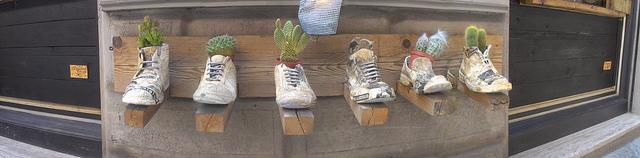What are the shoes used for?
Be succinct. Planters. How many shoes are displayed?
Be succinct. 6. Is this art?
Quick response, please. Yes. 